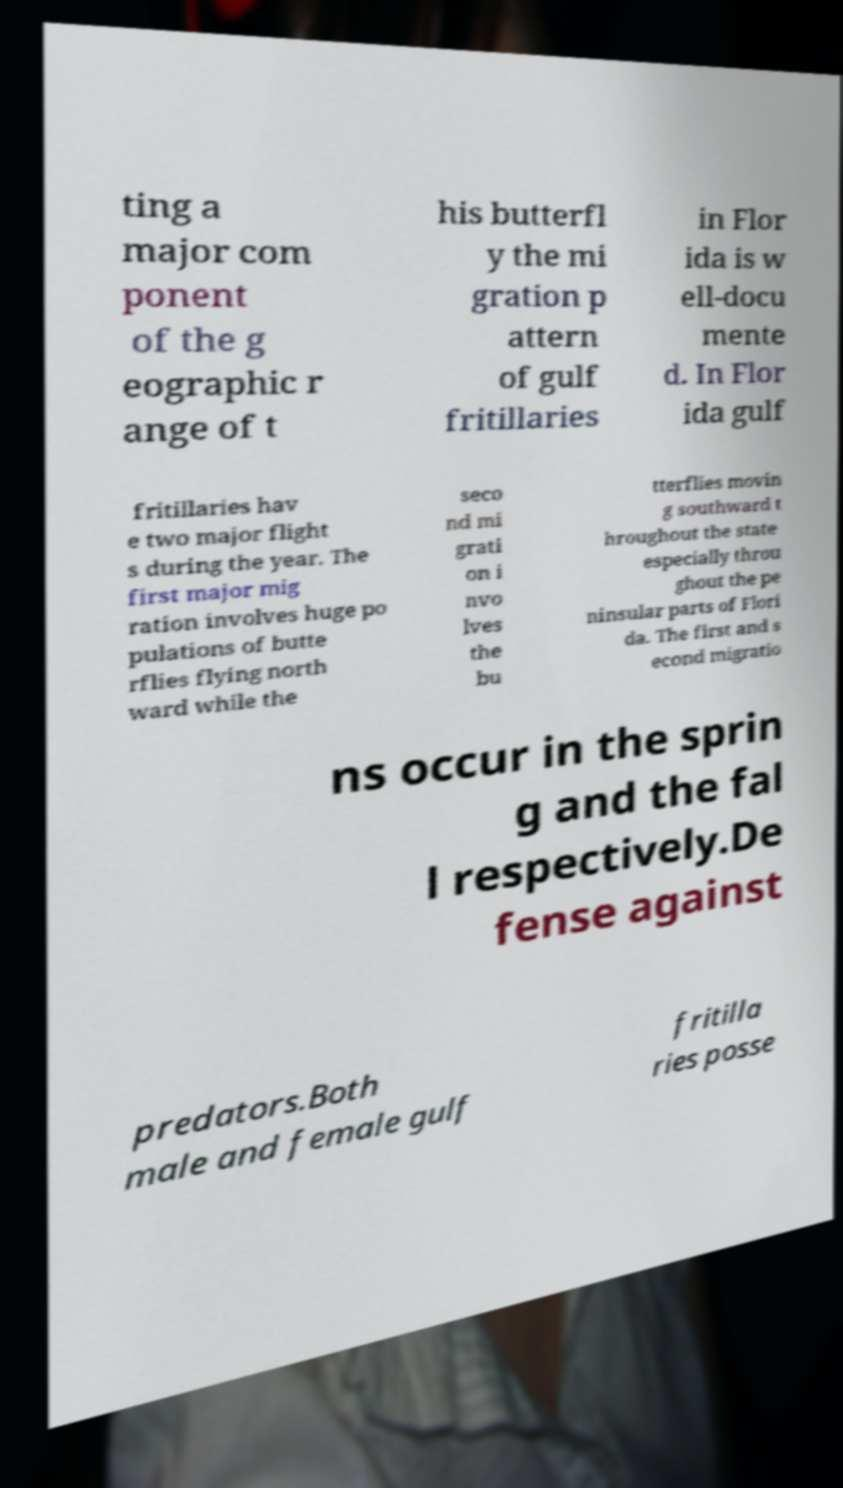For documentation purposes, I need the text within this image transcribed. Could you provide that? ting a major com ponent of the g eographic r ange of t his butterfl y the mi gration p attern of gulf fritillaries in Flor ida is w ell-docu mente d. In Flor ida gulf fritillaries hav e two major flight s during the year. The first major mig ration involves huge po pulations of butte rflies flying north ward while the seco nd mi grati on i nvo lves the bu tterflies movin g southward t hroughout the state especially throu ghout the pe ninsular parts of Flori da. The first and s econd migratio ns occur in the sprin g and the fal l respectively.De fense against predators.Both male and female gulf fritilla ries posse 